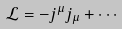Convert formula to latex. <formula><loc_0><loc_0><loc_500><loc_500>\mathcal { L } = - j ^ { \mu } j _ { \mu } + \cdots</formula> 